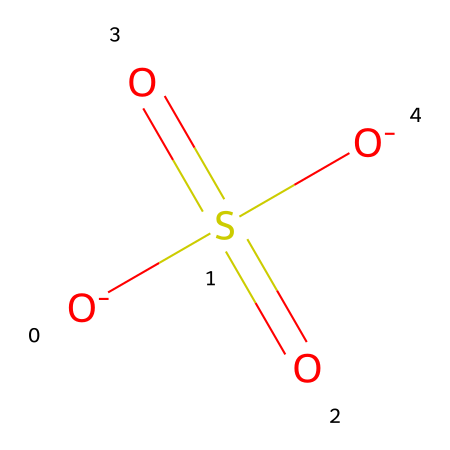What is the central atom in this compound? The chemical structure shows a sulfur atom surrounded by four oxygens. The sulfur atom is typically the central atom in hypervalent compounds, making it the focus of the molecular structure.
Answer: sulfur How many oxygen atoms are present in this compound? Observing the structure, there are four oxygen atoms connected to the sulfur atom. Two of them are part of the sulfate group, and the other two are negatively charged ions interacting with sulfur.
Answer: four What type of bonds are present between sulfur and oxygen in this compound? This compound shows double bonds between sulfur and two oxygen atoms, while the other two oxygen atoms are single bonds with formal negative charges, indicating that there are covalent bonds in the structure.
Answer: covalent Is this compound considered a hypervalent compound? The presence of a sulfur atom that exceeds the octet rule by forming bonds with more than four substituents (in this case, four oxygens) classifies it as hypervalent.
Answer: yes What form of sulfur is involved in this compound? The structure indicates that the sulfur atom in this compound is in a +6 oxidation state, typical for sulfur in sulfates and similar hypervalent compounds.
Answer: +6 How many formal charges are present in this compound? By assessing the structure, it is observable that there are two negatively charged oxygen atoms, leading to a total of two formal charges on the molecule.
Answer: two What main role does this compound play in iron gall ink? This compound contributes to the acidity and color stability of iron gall ink, which is critical in traditional ink making for artists.
Answer: acidity 